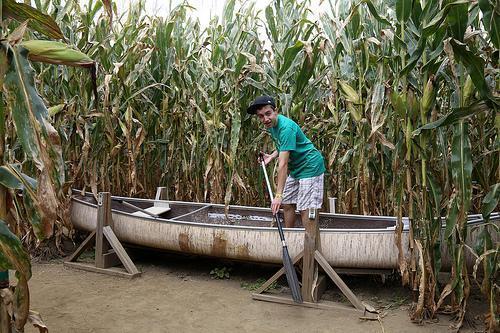How many oars does the boy have?
Give a very brief answer. 1. How many boats are there?
Give a very brief answer. 1. 